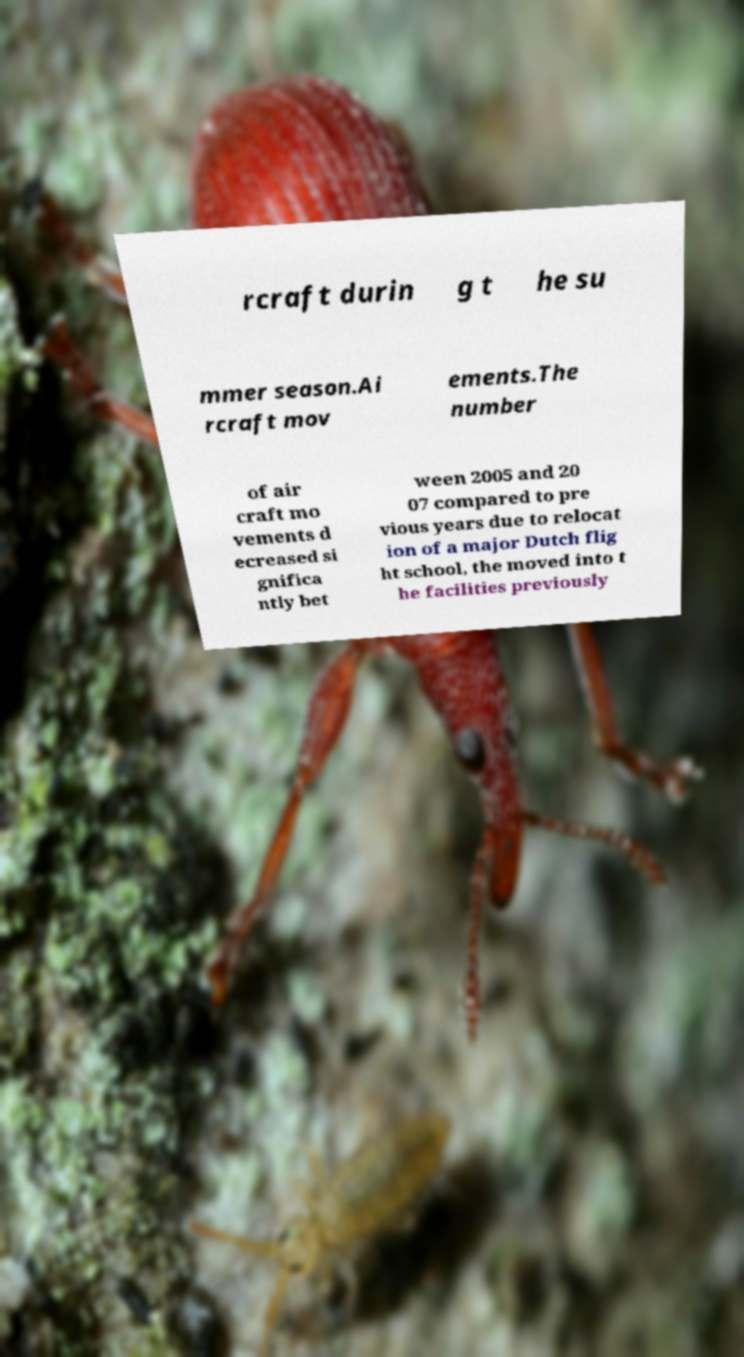Please read and relay the text visible in this image. What does it say? rcraft durin g t he su mmer season.Ai rcraft mov ements.The number of air craft mo vements d ecreased si gnifica ntly bet ween 2005 and 20 07 compared to pre vious years due to relocat ion of a major Dutch flig ht school, the moved into t he facilities previously 